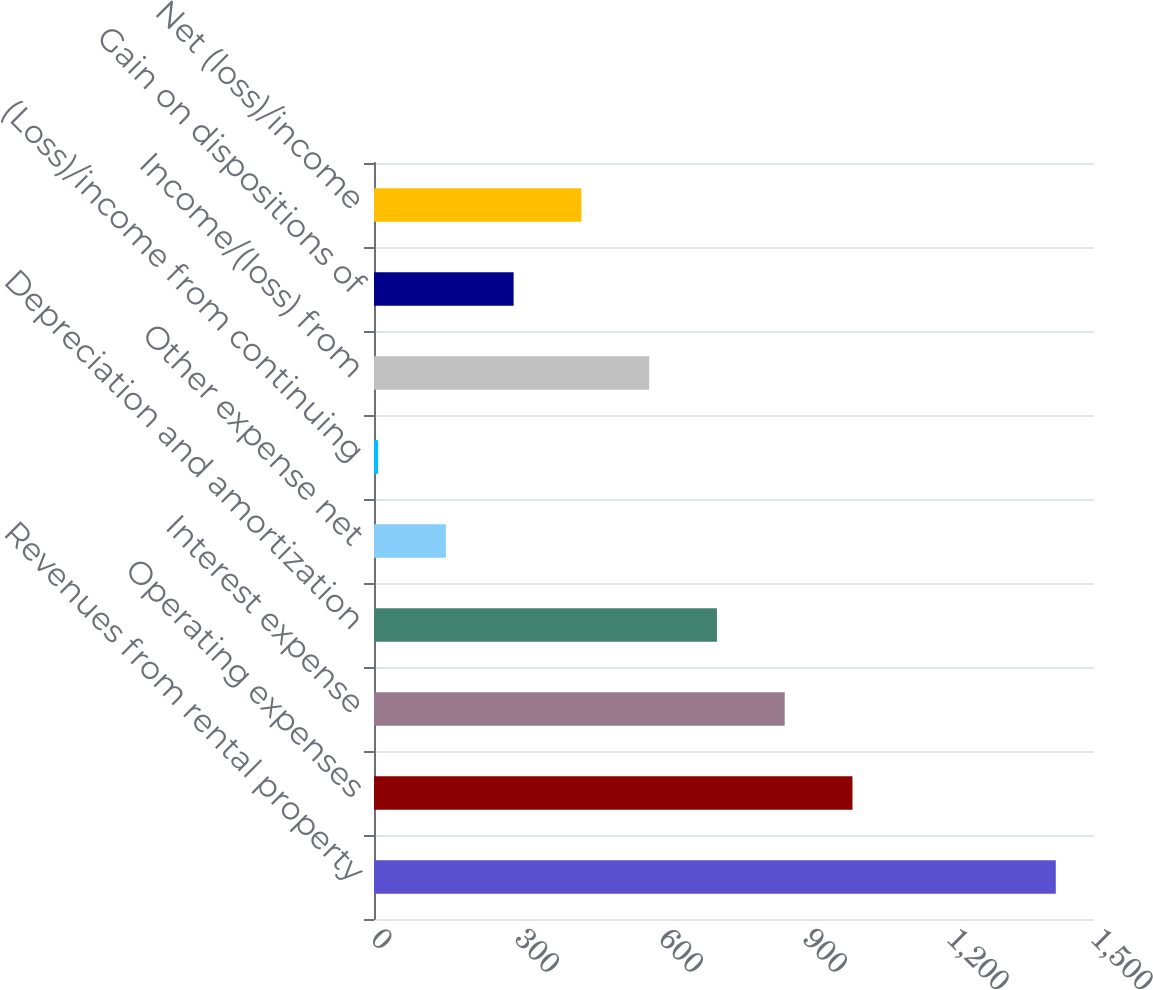<chart> <loc_0><loc_0><loc_500><loc_500><bar_chart><fcel>Revenues from rental property<fcel>Operating expenses<fcel>Interest expense<fcel>Depreciation and amortization<fcel>Other expense net<fcel>(Loss)/income from continuing<fcel>Income/(loss) from<fcel>Gain on dispositions of<fcel>Net (loss)/income<nl><fcel>1420.4<fcel>996.83<fcel>855.64<fcel>714.45<fcel>149.69<fcel>8.5<fcel>573.26<fcel>290.88<fcel>432.07<nl></chart> 